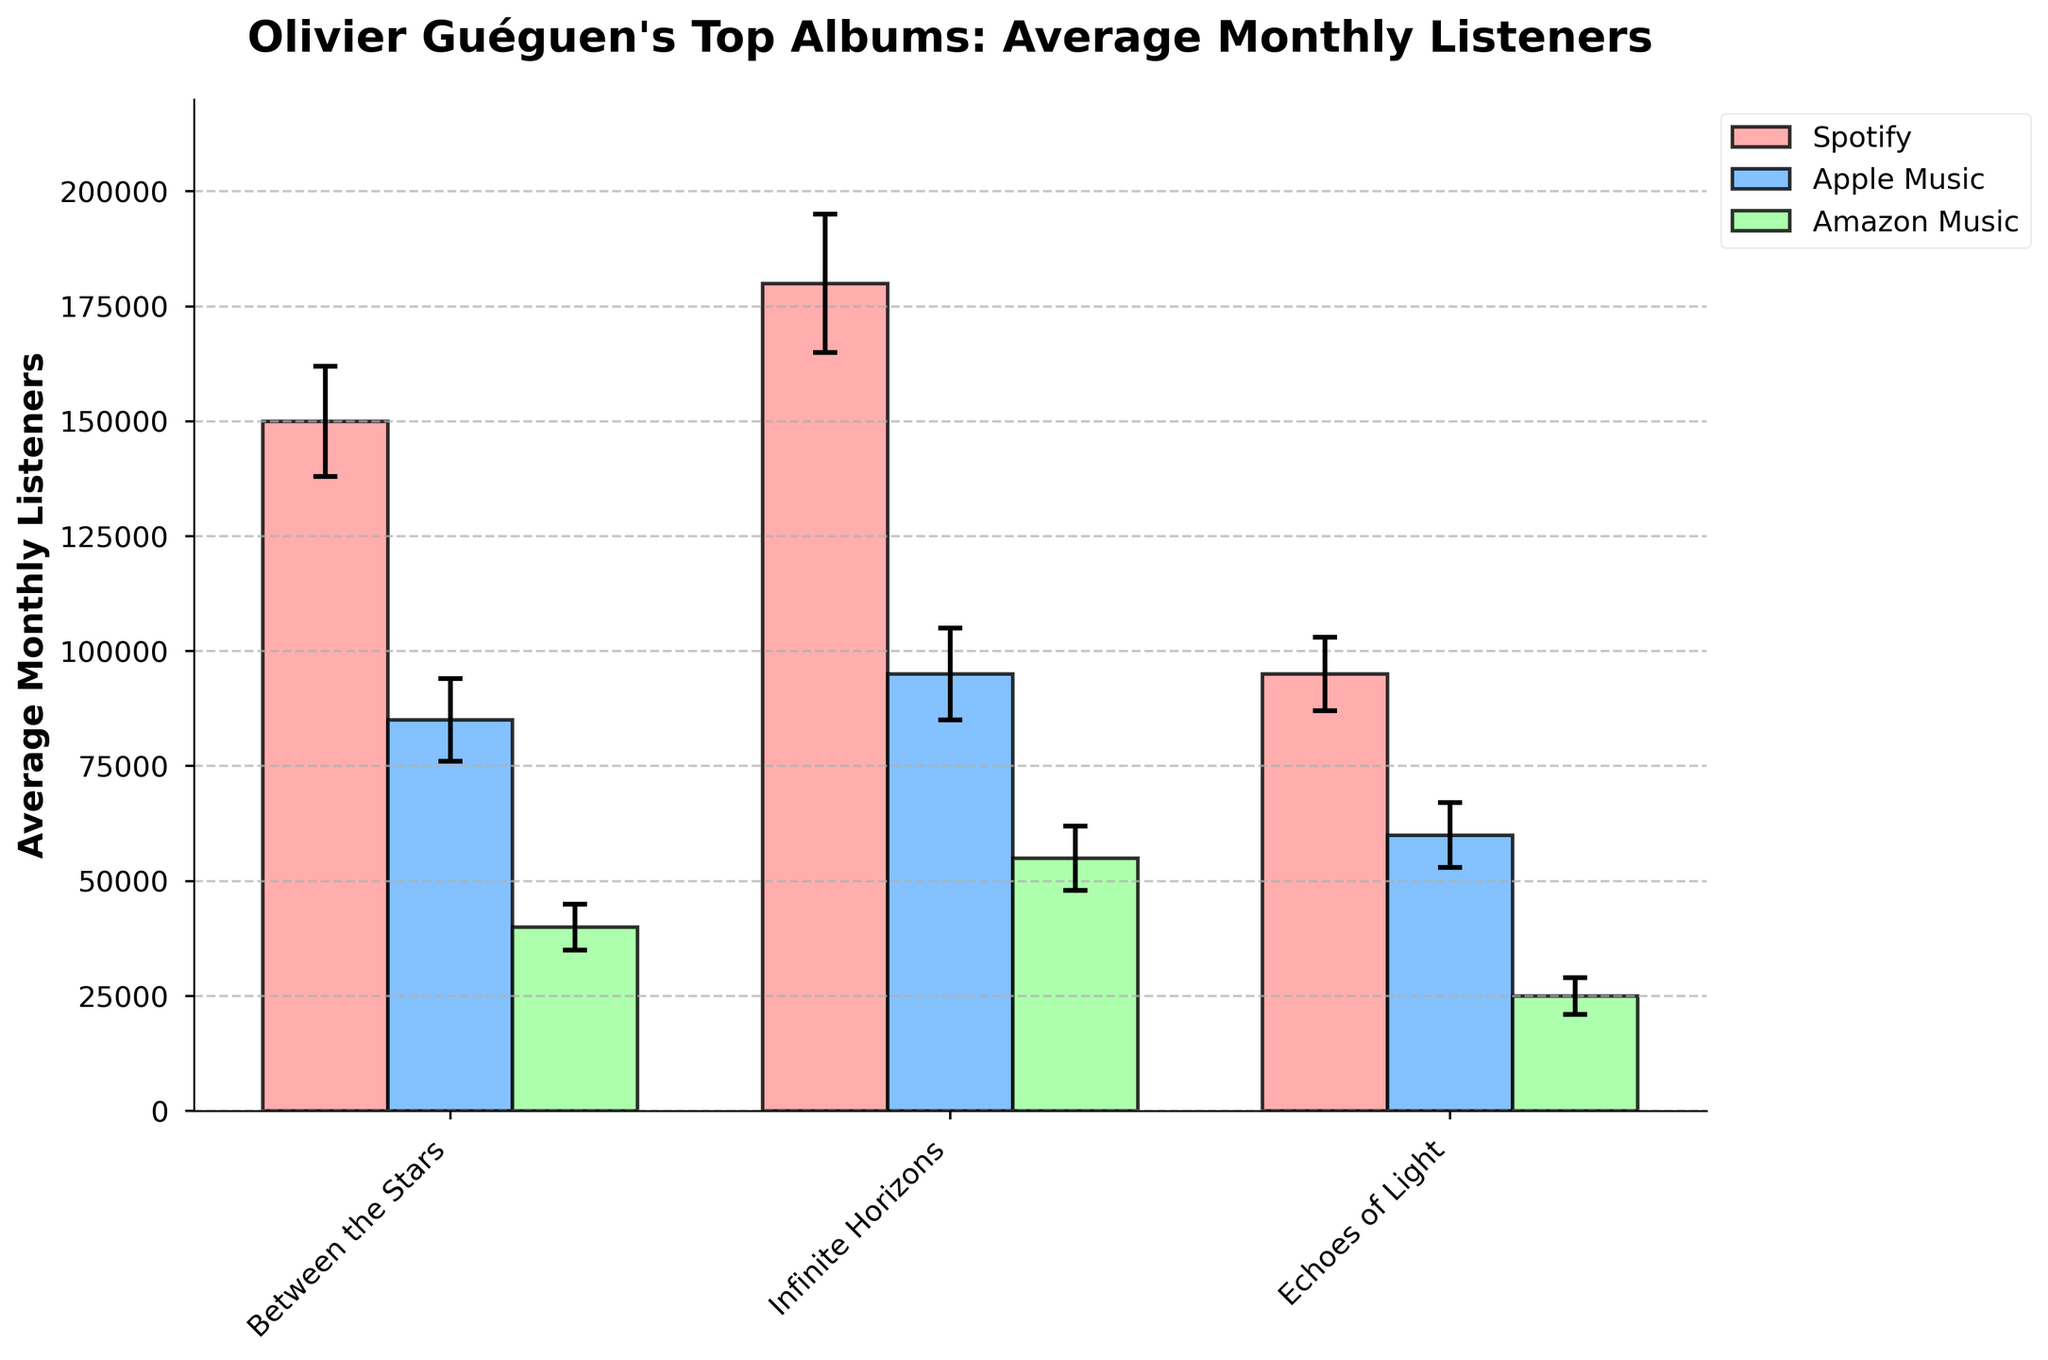What's the average monthly listeners for "Between the Stars" on Spotify? The average monthly listeners for "Between the Stars" on Spotify can be found by looking at the height of the corresponding bar on the chart.
Answer: 150,000 Which album has the highest average monthly listeners on Apple Music? To determine this, compare the heights of the bars representing Apple Music listeners for each album. The highest bar corresponds to the album "Infinite Horizons."
Answer: Infinite Horizons What's the difference in average monthly listeners between "Echoes of Light" on Spotify and Amazon Music? First, find the average monthly listeners for "Echoes of Light" on Spotify (95,000) and then for "Echoes of Light" on Amazon Music (25,000). Subtract the latter from the former to find the difference.
Answer: 70,000 Which platform has the highest variability in listeners for "Between the Stars"? To determine the platform with the highest variability, look at the error bars for "Between the Stars" on each platform. The error bar for Spotify is the largest, indicating the highest standard deviation.
Answer: Spotify How do the average listeners of "Infinite Horizons" on Amazon Music compare to "Echoes of Light" on Spotify? The average monthly listeners for "Infinite Horizons" on Amazon Music is 55,000, and for "Echoes of Light" on Spotify is 95,000. Comparing these values, "Echoes of Light" has more listeners.
Answer: Echoes of Light on Spotify has more listeners What is the sum of average monthly listeners for "Between the Stars" across all platforms? Add the average listeners for "Between the Stars" on Spotify (150,000), Apple Music (85,000), and Amazon Music (40,000). The sum is 150,000 + 85,000 + 40,000 = 275,000.
Answer: 275,000 What’s the ratio of average monthly listeners for "Between the Stars" on Spotify to "Infinite Horizons" on Apple Music? The average monthly listeners for "Between the Stars" on Spotify is 150,000, and for "Infinite Horizons" on Apple Music is 95,000. The ratio is 150,000 / 95,000 = 1.58.
Answer: 1.58 Which album and platform combination shows the lowest average monthly listeners? Look for the shortest bar in the chart. The bar for "Echoes of Light" on Amazon Music is the shortest, indicating the lowest average monthly listeners.
Answer: Echoes of Light on Amazon Music Are the average listeners for "Infinite Horizons" on Apple Music greater than those for "Between the Stars" on Spotify? The average listeners for "Infinite Horizons" on Apple Music are 95,000, whereas for "Between the Stars" on Spotify are 150,000. Since 95,000 is less than 150,000, the answer is no.
Answer: No What’s the highest standard deviation observed among all combinations? Check the error bars to find the highest standard deviation value. The largest error bar corresponds to "Infinite Horizons" on Spotify with a standard deviation of 15,000.
Answer: 15,000 